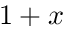Convert formula to latex. <formula><loc_0><loc_0><loc_500><loc_500>1 + x</formula> 